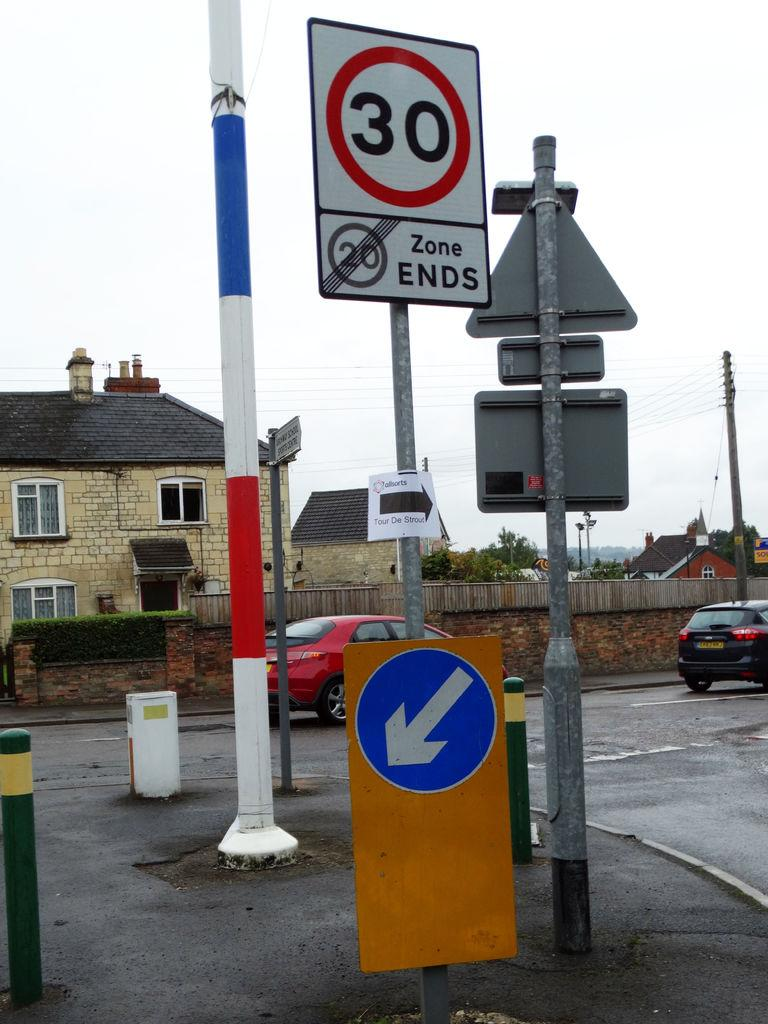<image>
Render a clear and concise summary of the photo. Two street signs sit back to back with one reading 30 with a red circle around it. 